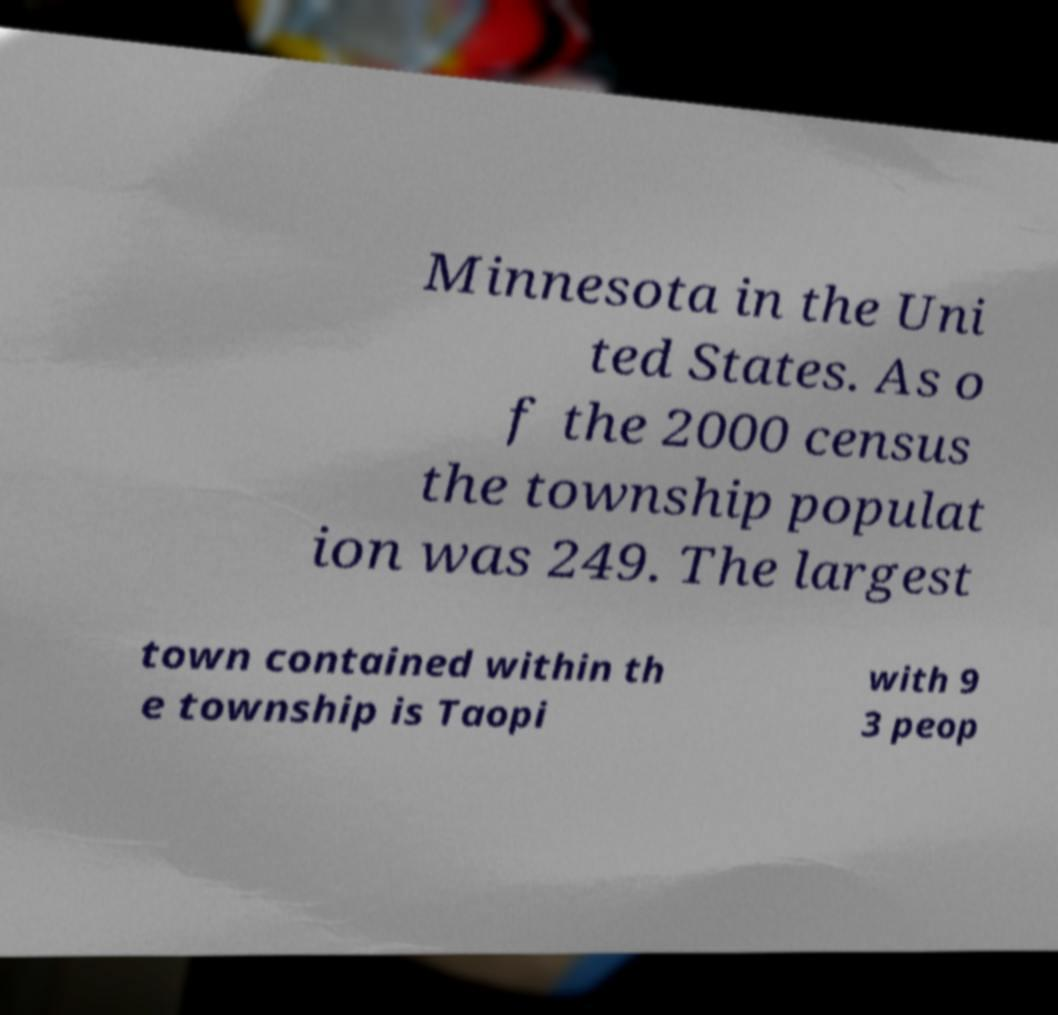Could you assist in decoding the text presented in this image and type it out clearly? Minnesota in the Uni ted States. As o f the 2000 census the township populat ion was 249. The largest town contained within th e township is Taopi with 9 3 peop 